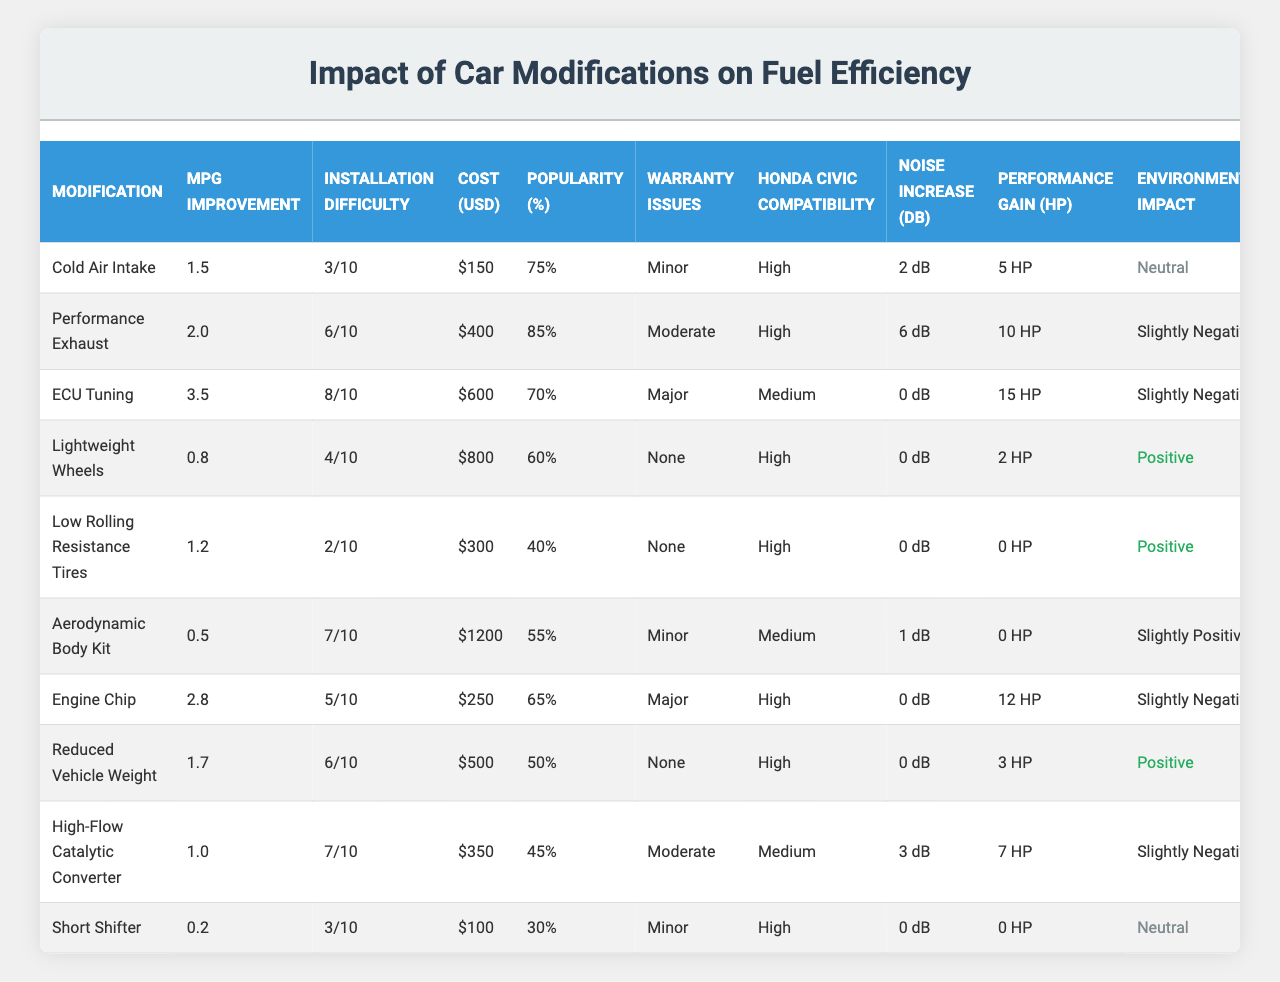What is the average MPG improvement for all modifications combined? To find the average MPG improvement, we sum all the individual MPG improvements: (1.5 + 2.0 + 3.5 + 0.8 + 1.2 + 0.5 + 2.8 + 1.7 + 1.0 + 0.2) = 15.7. There are 10 modifications, so we divide 15.7 by 10, resulting in an average of 1.57 MPG improvement.
Answer: 1.57 Which modification has the highest average MPG improvement? By reviewing the MPG improvement column, the highest value is 3.5, corresponding to ECU Tuning.
Answer: ECU Tuning How many modifications have a popularity rating above 70%? We can count the modifications with popularity percentages higher than 70%. The modifications Cold Air Intake, Performance Exhaust, and Engine Chip meet this criterion, totaling 3.
Answer: 3 What is the installation difficulty rating of the Performance Exhaust modification? The table states that the installation difficulty rating for Performance Exhaust is 6 out of 10.
Answer: 6/10 Which modification has the lowest installation difficulty, and what is that value? The modification with the lowest installation difficulty is Low Rolling Resistance Tires, with a rating of 2 out of 10.
Answer: Low Rolling Resistance Tires, 2/10 Is there a modification with no potential warranty issues? By checking the potential warranty issues column, both Lightweight Wheels and Reduced Vehicle Weight have "None" listed as their potential warranty issues. Therefore, the answer is yes.
Answer: Yes What is the difference in average cost between the most and least expensive modifications? The most expensive modification is Aerodynamic Body Kit at $1200, and the least expensive is Short Shifter at $100. The difference in cost is $1200 - $100 = $1100.
Answer: $1100 Which modification has the highest performance gain in HP? The maximum performance gain in HP is 15 HP, attributed to ECU Tuning.
Answer: ECU Tuning How many modifications increase noise level by more than 2 dB? By inspecting the noise level increase column, only Performance Exhaust increases noise by 6 dB, while others are 2 dB or less, leading to a total of 1 modification.
Answer: 1 Does the Environmental Impact of the Performance Exhaust modification carry a slightly negative effect? The Environmental Impact for Performance Exhaust shows "Slightly Negative," confirming this is true.
Answer: Yes What percentage of enthusiasts prefer Performance Exhaust over Lightweight Wheels? Performance Exhaust has a popularity of 85%, while Lightweight Wheels stands at 60%. Thus, the preference difference is 25%.
Answer: 25% 